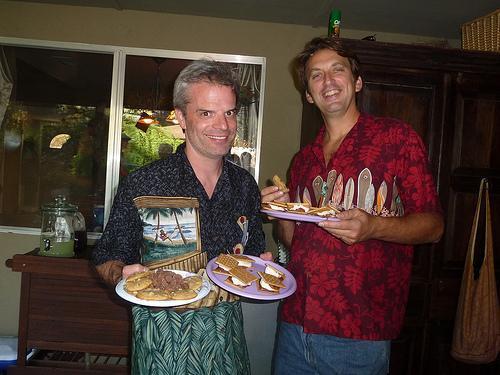How many people are there?
Give a very brief answer. 2. 